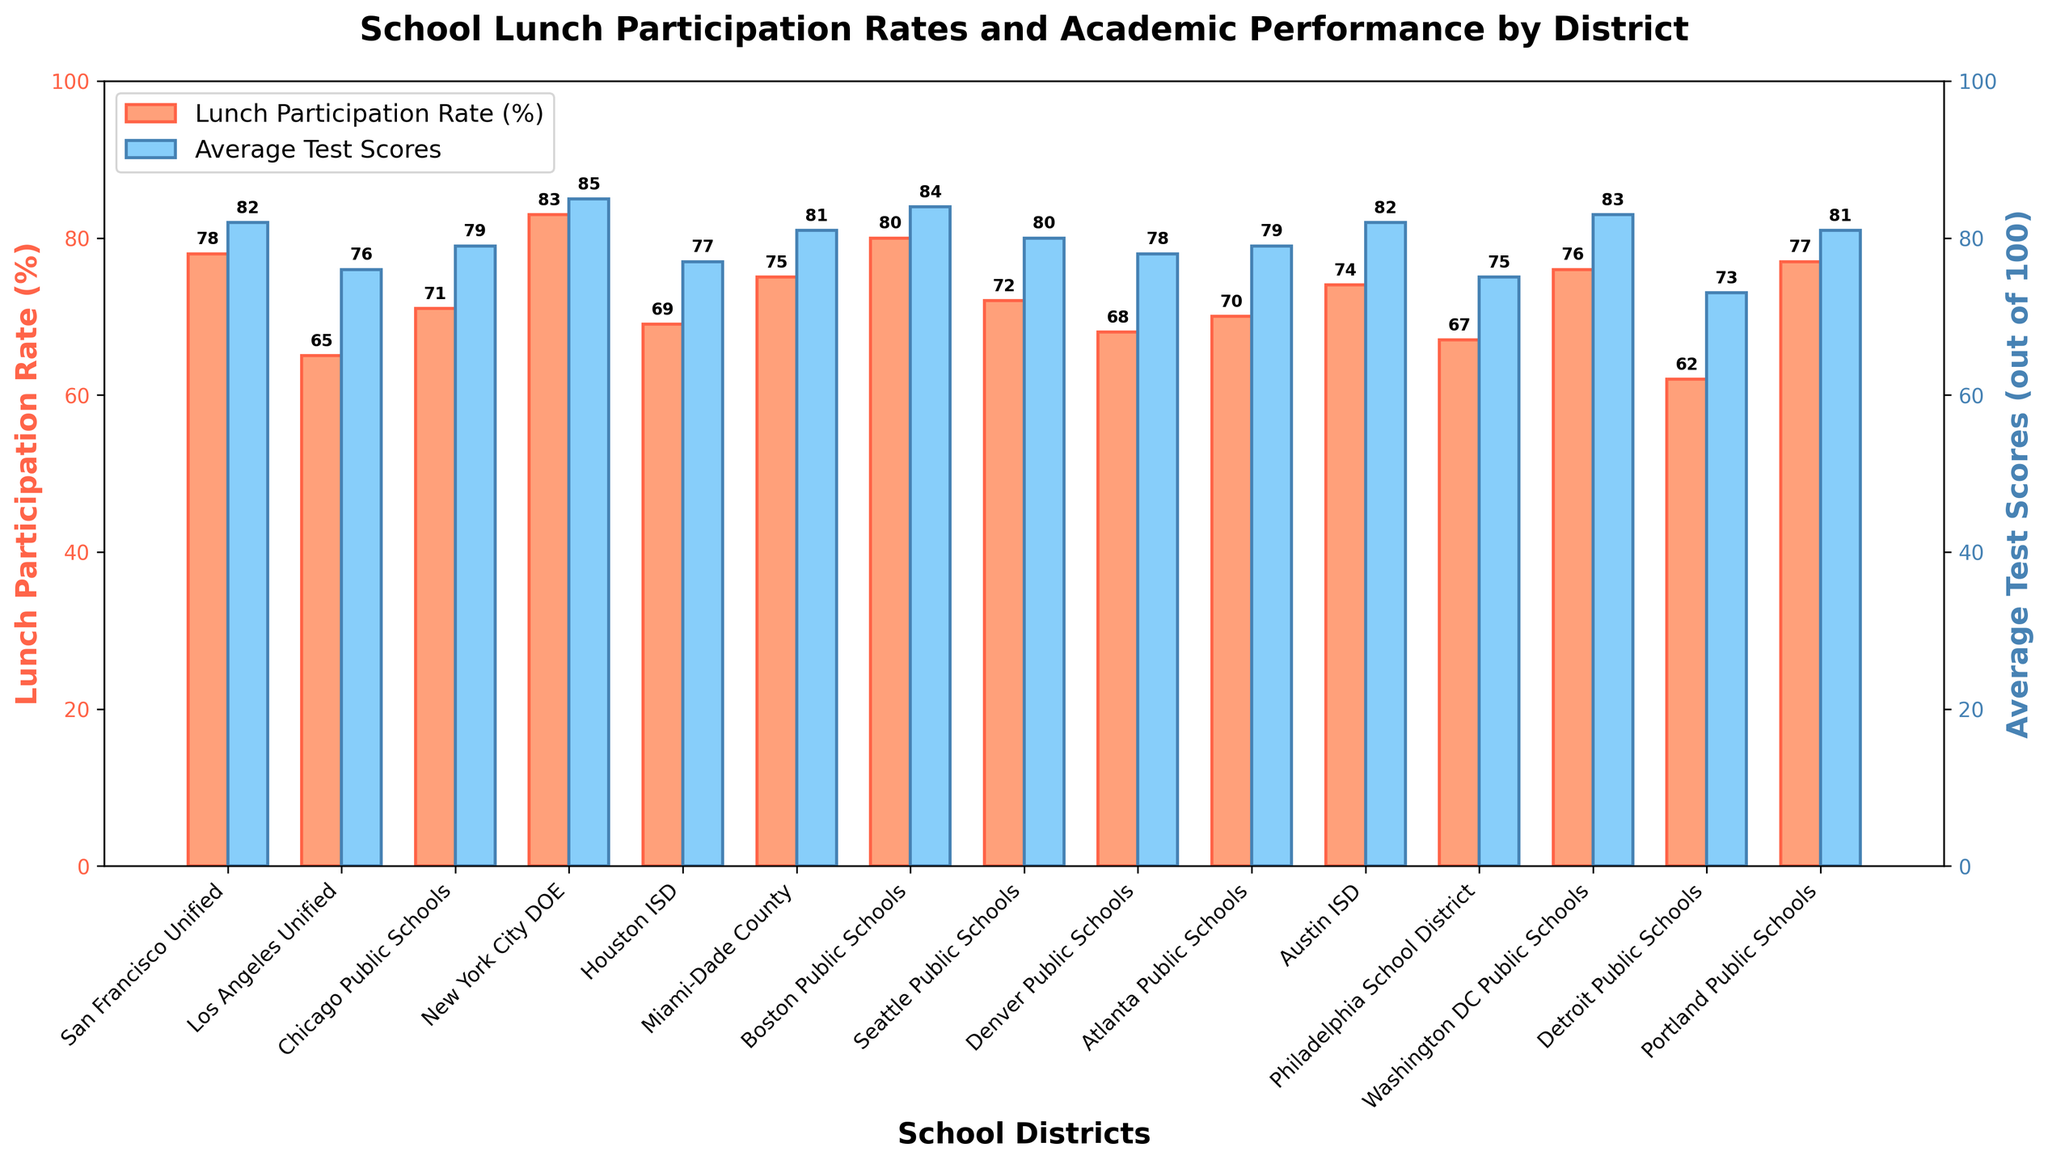What is the lunch participation rate of the district with the highest average test score? Identify the district with the highest average test score by comparing each value. The highest average test score is 85 in New York City DOE. Then, look for the lunch participation rate for New York City DOE, which is 83%.
Answer: 83% Which district has the lowest lunch participation rate? Compare the lunch participation rates of all districts to find the lowest one. Detroit Public Schools have the lowest participation rate at 62%.
Answer: Detroit Public Schools What is the average lunch participation rate among the given districts? Sum all lunch participation rates and divide by the number of districts. Sum = 78 + 65 + 71 + 83 + 69 + 75 + 80 + 72 + 68 + 70 + 74 + 67 + 76 + 62 + 77 = 1117. There are 15 districts. Average = 1117 / 15 ≈ 74.47.
Answer: 74.47% Does a higher lunch participation rate generally correlate with higher average test scores? Observe trends from the bars in the chart. New York City DOE and Boston Public Schools, which have higher participation rates of 83% and 80% respectively, have high test scores of 85 and 84. On the other hand, Detroit Public Schools with the lowest rate (62%) have a lower test score (73). This pattern suggests a correlation.
Answer: Yes Which two districts have the same lunch participation rate but different average test scores? Look for districts with matching lunch participation rates. San Francisco Unified and Portland Public Schools both have a lunch participation rate of 77%. Their average test scores are different, with 82 and 81, respectively.
Answer: San Francisco Unified and Portland Public Schools What is the total number of districts where the average test score is less than 80? Count all districts with average test scores below 80 by comparing each score against the value 80. Los Angeles Unified (76), Chicago Public Schools (79), Houston ISD (77), Seattle Public Schools (80), Denver Public Schools (78), Atlanta Public Schools (79), Austin ISD (82), Philadelphia School District (75), Detroit Public Schools (73).
Answer: 8 What is the median average test score among the districts? Arrange all average test scores in ascending order and find the middle value. Scores in order: 73, 75, 76, 77, 78, 79, 79, 80, 81, 81, 82, 82, 83, 84, 85. Median is the 8th value, which is 80.
Answer: 80 Compare the lunch participation rates of Miami-Dade County and Boston Public Schools. Which one is higher, and by how much? Miami-Dade County has a lunch participation rate of 75%. Boston Public Schools has a rate of 80%. The difference is 80% - 75% = 5%.
Answer: Boston Public Schools by 5% 